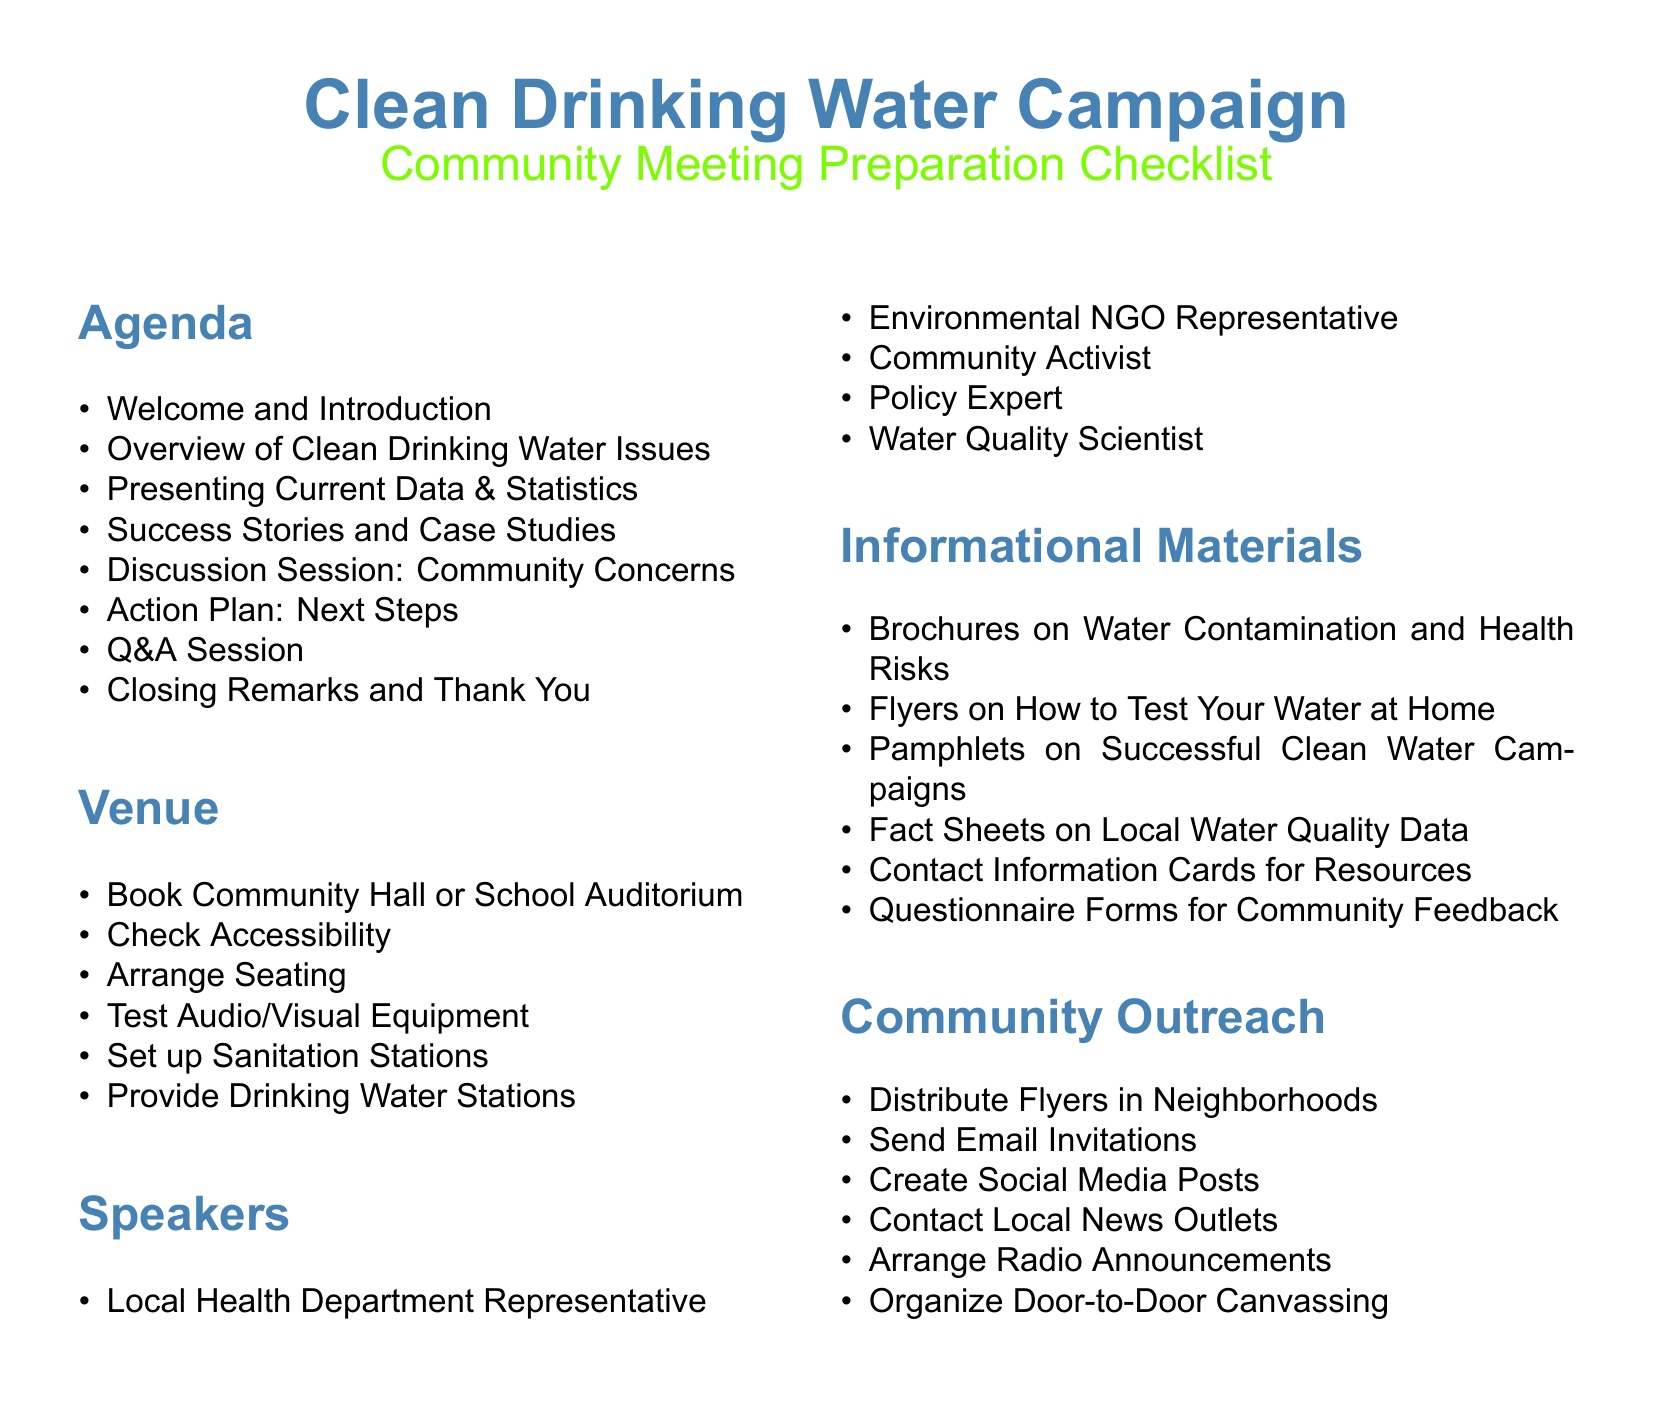What is the title of the checklist? The title of the checklist is prominently displayed at the top of the document, indicating the focus of the content.
Answer: Community Meeting Preparation Checklist How many sections are in the checklist? The checklist contains five distinct sections that cover various preparation topics.
Answer: 5 Who is one of the speakers mentioned in the checklist? The speakers listed in the document include various experts related to clean drinking water.
Answer: Local Health Department Representative What is one of the community outreach methods suggested? The document outlines several methods for reaching out to the community to ensure participation in the meeting.
Answer: Distribute Flyers in Neighborhoods What is one of the items to check for the venue? The checklist includes various practical considerations for the venue to ensure it meets the needs of the community meeting.
Answer: Check Accessibility What is the final item listed in the agenda? The agenda outlines all the key topics to be covered during the community meeting, ending with a closing interaction.
Answer: Closing Remarks and Thank You Name one type of informational material mentioned. The checklist specifies several types of materials that can inform attendees about clean drinking water issues.
Answer: Brochures on Water Contamination and Health Risks How many speakers are listed in the document? The document provides a list of different speakers that are expected to address the community during the meeting.
Answer: 5 